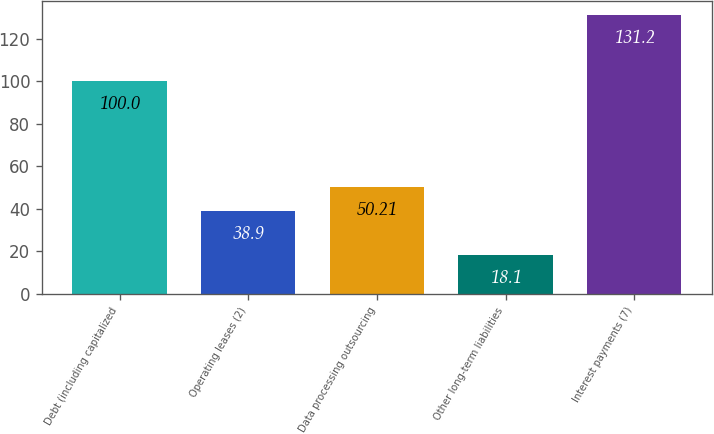<chart> <loc_0><loc_0><loc_500><loc_500><bar_chart><fcel>Debt (including capitalized<fcel>Operating leases (2)<fcel>Data processing outsourcing<fcel>Other long-term liabilities<fcel>Interest payments (7)<nl><fcel>100<fcel>38.9<fcel>50.21<fcel>18.1<fcel>131.2<nl></chart> 